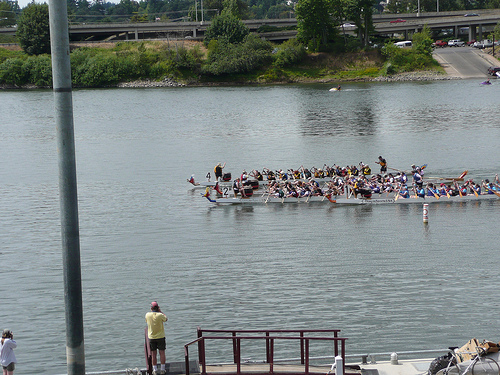<image>
Is there a man behind the water? No. The man is not behind the water. From this viewpoint, the man appears to be positioned elsewhere in the scene. 